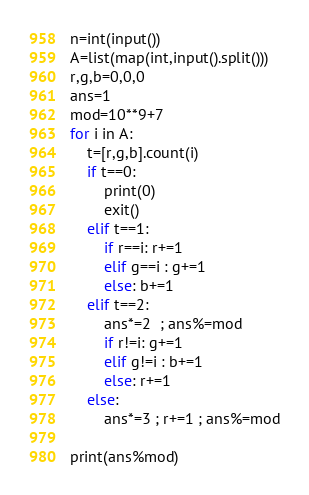Convert code to text. <code><loc_0><loc_0><loc_500><loc_500><_Python_>n=int(input())
A=list(map(int,input().split()))
r,g,b=0,0,0
ans=1
mod=10**9+7
for i in A:
    t=[r,g,b].count(i)
    if t==0:
        print(0)
        exit()
    elif t==1:
        if r==i: r+=1
        elif g==i : g+=1
        else: b+=1
    elif t==2:
        ans*=2  ; ans%=mod
        if r!=i: g+=1
        elif g!=i : b+=1
        else: r+=1
    else:
        ans*=3 ; r+=1 ; ans%=mod

print(ans%mod)</code> 